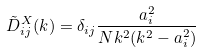Convert formula to latex. <formula><loc_0><loc_0><loc_500><loc_500>\tilde { D } _ { i j } ^ { X } ( k ) = \delta _ { i j } \frac { a _ { i } ^ { 2 } } { N k ^ { 2 } ( k ^ { 2 } - a _ { i } ^ { 2 } ) }</formula> 